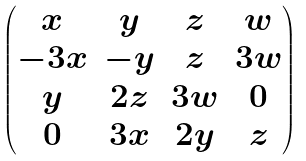<formula> <loc_0><loc_0><loc_500><loc_500>\begin{pmatrix} x & y & z & w \\ - 3 x & - y & z & 3 w \\ y & 2 z & 3 w & 0 \\ 0 & 3 x & 2 y & z \end{pmatrix}</formula> 